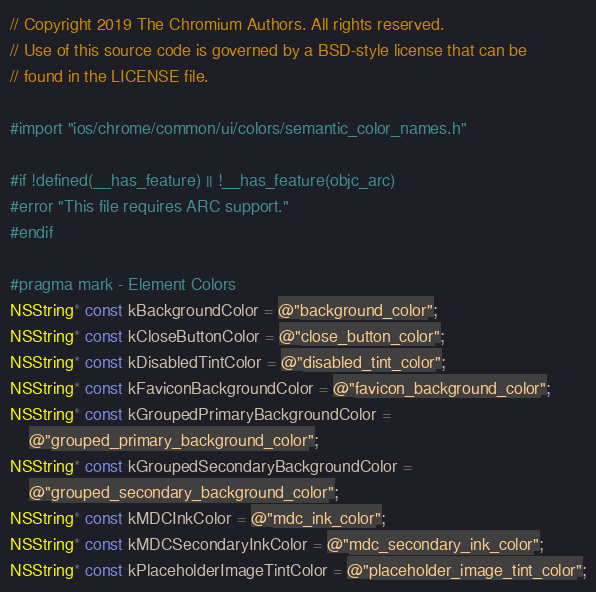<code> <loc_0><loc_0><loc_500><loc_500><_ObjectiveC_>// Copyright 2019 The Chromium Authors. All rights reserved.
// Use of this source code is governed by a BSD-style license that can be
// found in the LICENSE file.

#import "ios/chrome/common/ui/colors/semantic_color_names.h"

#if !defined(__has_feature) || !__has_feature(objc_arc)
#error "This file requires ARC support."
#endif

#pragma mark - Element Colors
NSString* const kBackgroundColor = @"background_color";
NSString* const kCloseButtonColor = @"close_button_color";
NSString* const kDisabledTintColor = @"disabled_tint_color";
NSString* const kFaviconBackgroundColor = @"favicon_background_color";
NSString* const kGroupedPrimaryBackgroundColor =
    @"grouped_primary_background_color";
NSString* const kGroupedSecondaryBackgroundColor =
    @"grouped_secondary_background_color";
NSString* const kMDCInkColor = @"mdc_ink_color";
NSString* const kMDCSecondaryInkColor = @"mdc_secondary_ink_color";
NSString* const kPlaceholderImageTintColor = @"placeholder_image_tint_color";</code> 